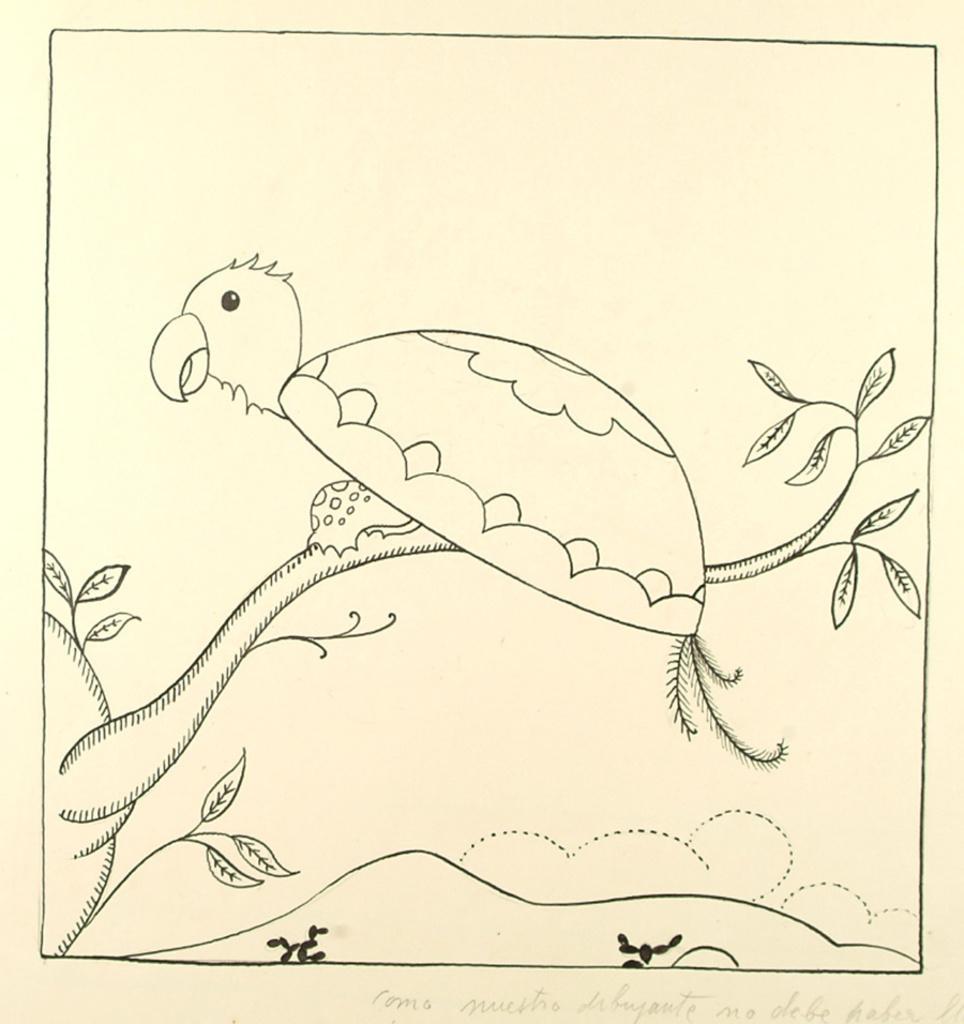Describe this image in one or two sentences. In this picture I can see the sketch of a bird, which is on a plant. I can see something is written on the bottom right of this picture. 